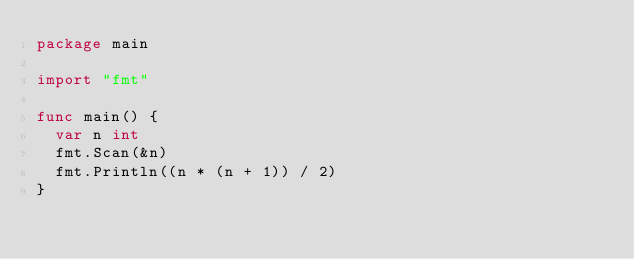<code> <loc_0><loc_0><loc_500><loc_500><_Go_>package main

import "fmt"

func main() {
	var n int
	fmt.Scan(&n)
	fmt.Println((n * (n + 1)) / 2)
}
</code> 